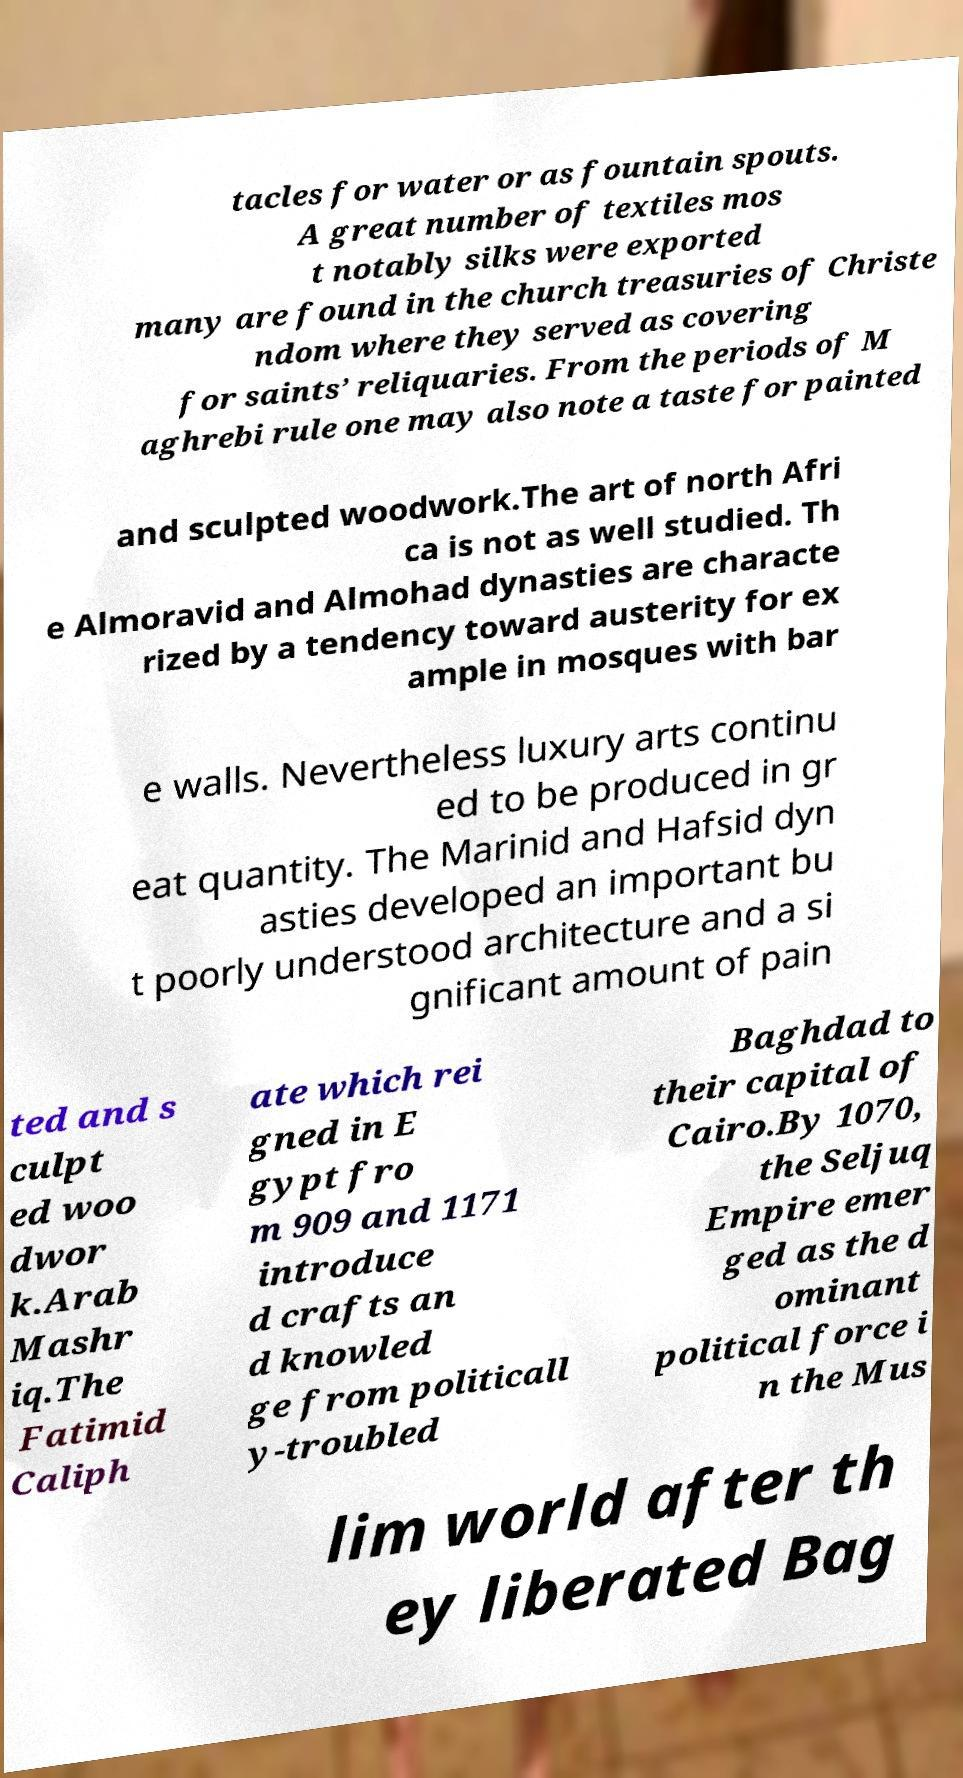Can you read and provide the text displayed in the image?This photo seems to have some interesting text. Can you extract and type it out for me? tacles for water or as fountain spouts. A great number of textiles mos t notably silks were exported many are found in the church treasuries of Christe ndom where they served as covering for saints’ reliquaries. From the periods of M aghrebi rule one may also note a taste for painted and sculpted woodwork.The art of north Afri ca is not as well studied. Th e Almoravid and Almohad dynasties are characte rized by a tendency toward austerity for ex ample in mosques with bar e walls. Nevertheless luxury arts continu ed to be produced in gr eat quantity. The Marinid and Hafsid dyn asties developed an important bu t poorly understood architecture and a si gnificant amount of pain ted and s culpt ed woo dwor k.Arab Mashr iq.The Fatimid Caliph ate which rei gned in E gypt fro m 909 and 1171 introduce d crafts an d knowled ge from politicall y-troubled Baghdad to their capital of Cairo.By 1070, the Seljuq Empire emer ged as the d ominant political force i n the Mus lim world after th ey liberated Bag 